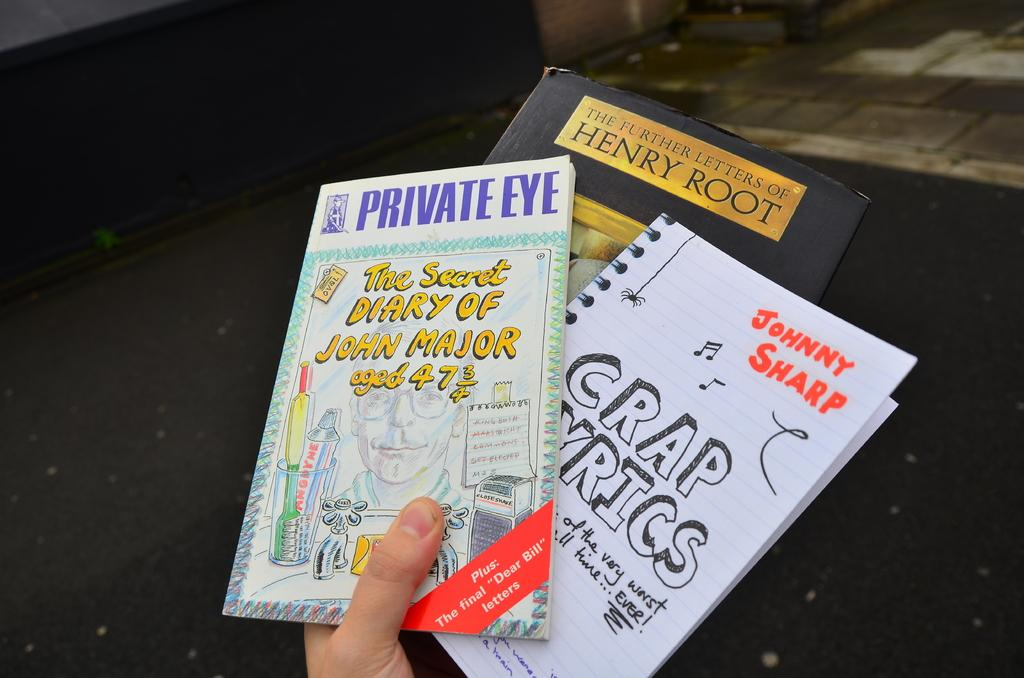<image>
Describe the image concisely. A person is holding three books including The Further Letters of Henry Root. 